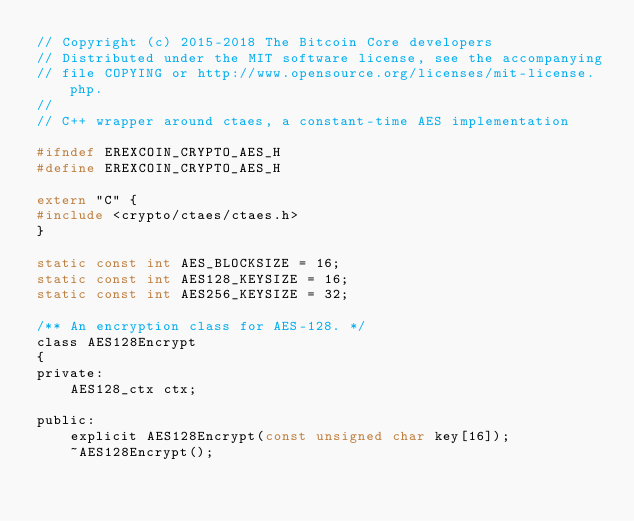Convert code to text. <code><loc_0><loc_0><loc_500><loc_500><_C_>// Copyright (c) 2015-2018 The Bitcoin Core developers
// Distributed under the MIT software license, see the accompanying
// file COPYING or http://www.opensource.org/licenses/mit-license.php.
//
// C++ wrapper around ctaes, a constant-time AES implementation

#ifndef EREXCOIN_CRYPTO_AES_H
#define EREXCOIN_CRYPTO_AES_H

extern "C" {
#include <crypto/ctaes/ctaes.h>
}

static const int AES_BLOCKSIZE = 16;
static const int AES128_KEYSIZE = 16;
static const int AES256_KEYSIZE = 32;

/** An encryption class for AES-128. */
class AES128Encrypt
{
private:
    AES128_ctx ctx;

public:
    explicit AES128Encrypt(const unsigned char key[16]);
    ~AES128Encrypt();</code> 